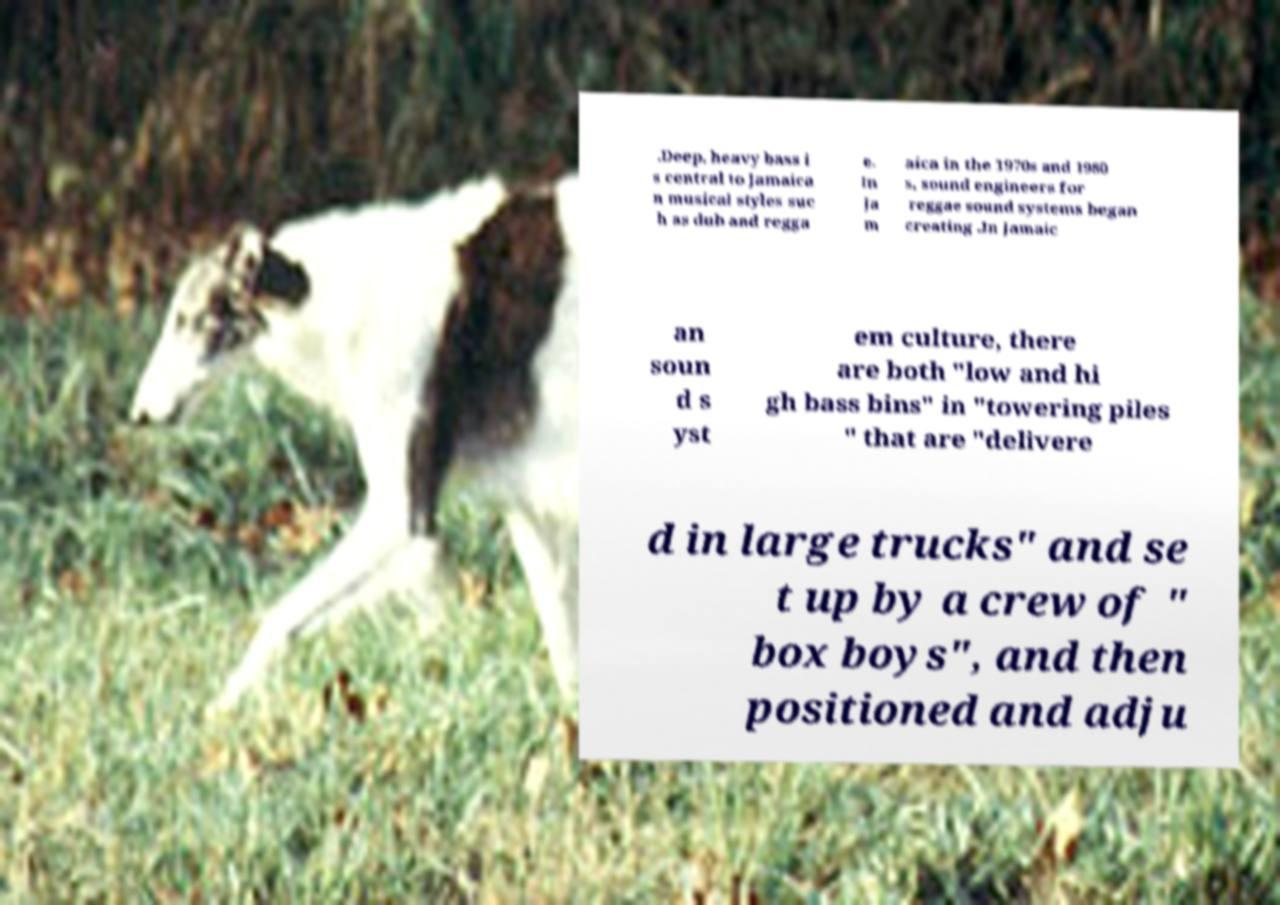Can you read and provide the text displayed in the image?This photo seems to have some interesting text. Can you extract and type it out for me? .Deep, heavy bass i s central to Jamaica n musical styles suc h as dub and regga e. In Ja m aica in the 1970s and 1980 s, sound engineers for reggae sound systems began creating .In Jamaic an soun d s yst em culture, there are both "low and hi gh bass bins" in "towering piles " that are "delivere d in large trucks" and se t up by a crew of " box boys", and then positioned and adju 